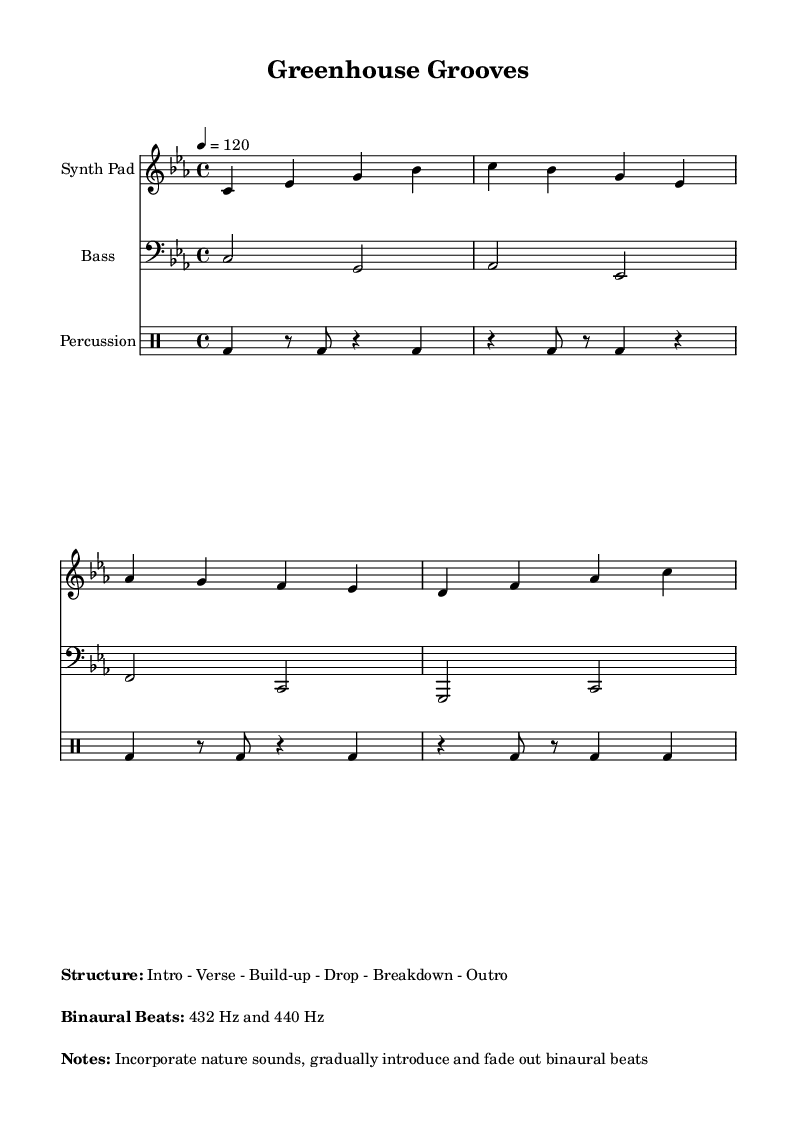What is the key signature of this music? The key signature is C minor, which has three flats (B-flat, E-flat, and A-flat). This is indicated in the global context where the key is set.
Answer: C minor What is the time signature used in the piece? The time signature is 4/4, meaning there are four beats per measure and the quarter note gets one beat. This is specified in the global context of the music.
Answer: 4/4 What is the tempo marking of the piece? The tempo marking is indicated as 120 beats per minute, which is shown by the instruction given in the global context "4 = 120".
Answer: 120 How many distinct sections are there in the structure of the music? The structure of the music consists of six sections: Intro, Verse, Build-up, Drop, Breakdown, and Outro. This is outlined in the markup section.
Answer: Six What frequencies of binaural beats are incorporated in this piece? The piece incorporates two specific frequencies: 432 Hz and 440 Hz. This is mentioned in the markup section under the "Binaural Beats" heading.
Answer: 432 Hz and 440 Hz Which instrument is playing the synth pad part in the score? The synth pad part is played on the treble clef, and it's specified in the staff header as "Synth Pad". This is indicated in the score where each instrument's name is labeled.
Answer: Synth Pad What type of drum rhythm is primarily used in this piece? The percussion section uses a drum pattern that includes bass drum hits and rests, specifically highlighted in the drummode section. This rhythmic structure is typical for deep house music, which often emphasizes bass beats.
Answer: Bass drum pattern 